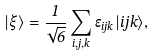Convert formula to latex. <formula><loc_0><loc_0><loc_500><loc_500>| \xi \rangle = \frac { 1 } { \sqrt { 6 } } \sum _ { i , j , k } \epsilon _ { i j k } | i j k \rangle ,</formula> 